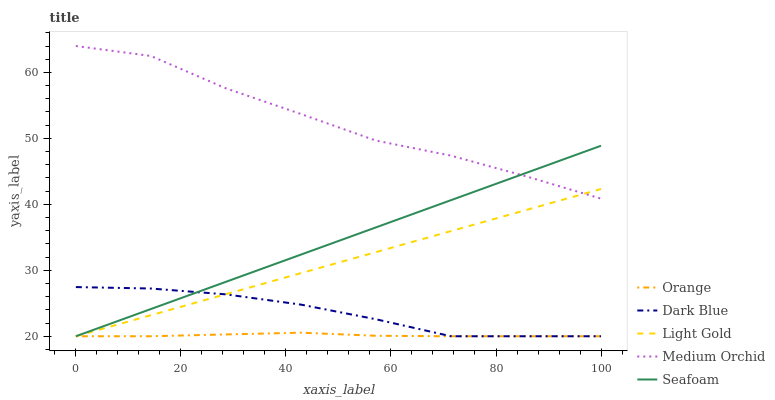Does Orange have the minimum area under the curve?
Answer yes or no. Yes. Does Medium Orchid have the maximum area under the curve?
Answer yes or no. Yes. Does Dark Blue have the minimum area under the curve?
Answer yes or no. No. Does Dark Blue have the maximum area under the curve?
Answer yes or no. No. Is Seafoam the smoothest?
Answer yes or no. Yes. Is Medium Orchid the roughest?
Answer yes or no. Yes. Is Dark Blue the smoothest?
Answer yes or no. No. Is Dark Blue the roughest?
Answer yes or no. No. Does Orange have the lowest value?
Answer yes or no. Yes. Does Medium Orchid have the lowest value?
Answer yes or no. No. Does Medium Orchid have the highest value?
Answer yes or no. Yes. Does Dark Blue have the highest value?
Answer yes or no. No. Is Dark Blue less than Medium Orchid?
Answer yes or no. Yes. Is Medium Orchid greater than Orange?
Answer yes or no. Yes. Does Dark Blue intersect Orange?
Answer yes or no. Yes. Is Dark Blue less than Orange?
Answer yes or no. No. Is Dark Blue greater than Orange?
Answer yes or no. No. Does Dark Blue intersect Medium Orchid?
Answer yes or no. No. 